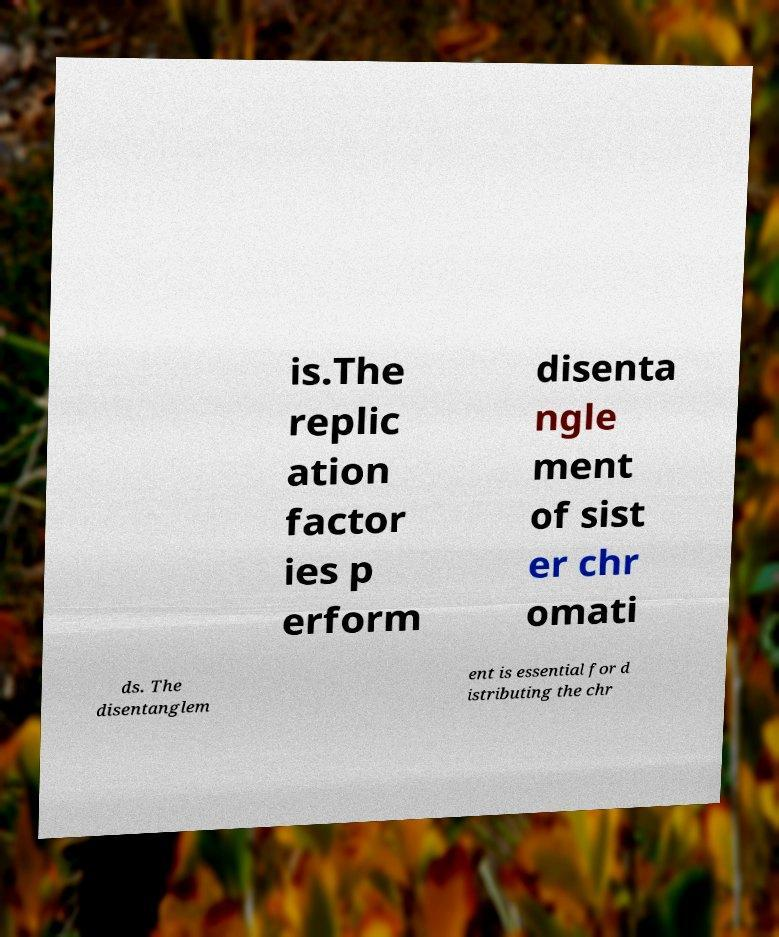Could you extract and type out the text from this image? is.The replic ation factor ies p erform disenta ngle ment of sist er chr omati ds. The disentanglem ent is essential for d istributing the chr 